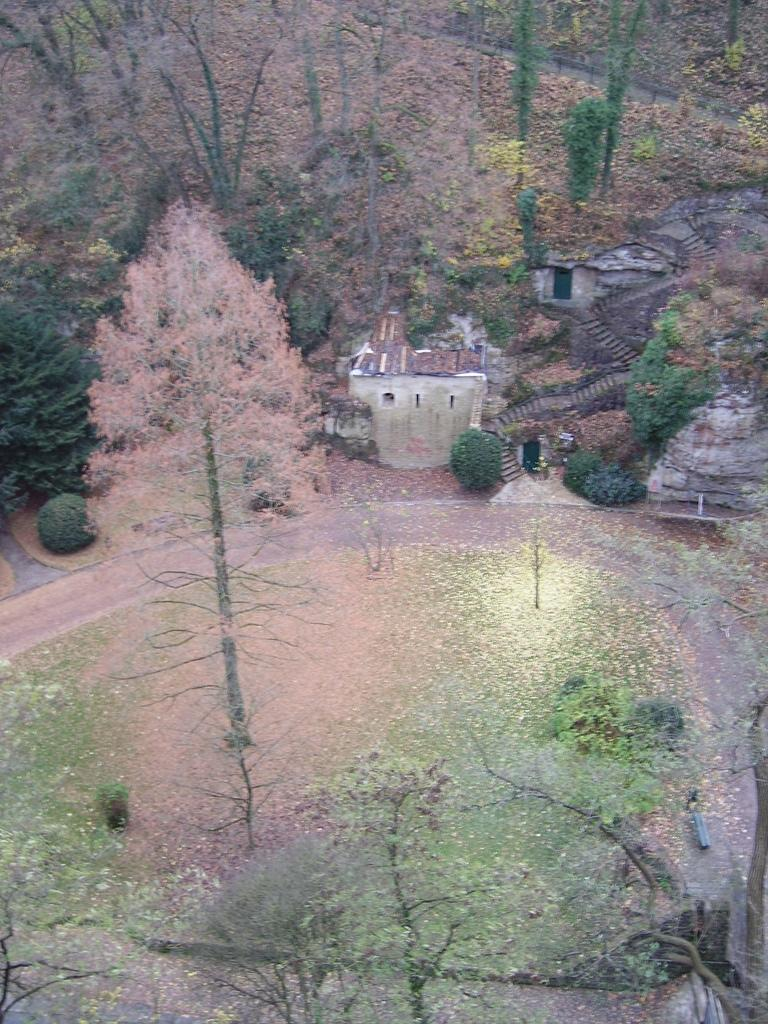What type of vegetation can be seen in the image? There are trees and plants in the image. What structure is located in the center of the image? There is a hut in the center of the image. What type of noise can be heard coming from the guitar in the image? There is no guitar present in the image, so it is not possible to determine what type of noise might be heard. 